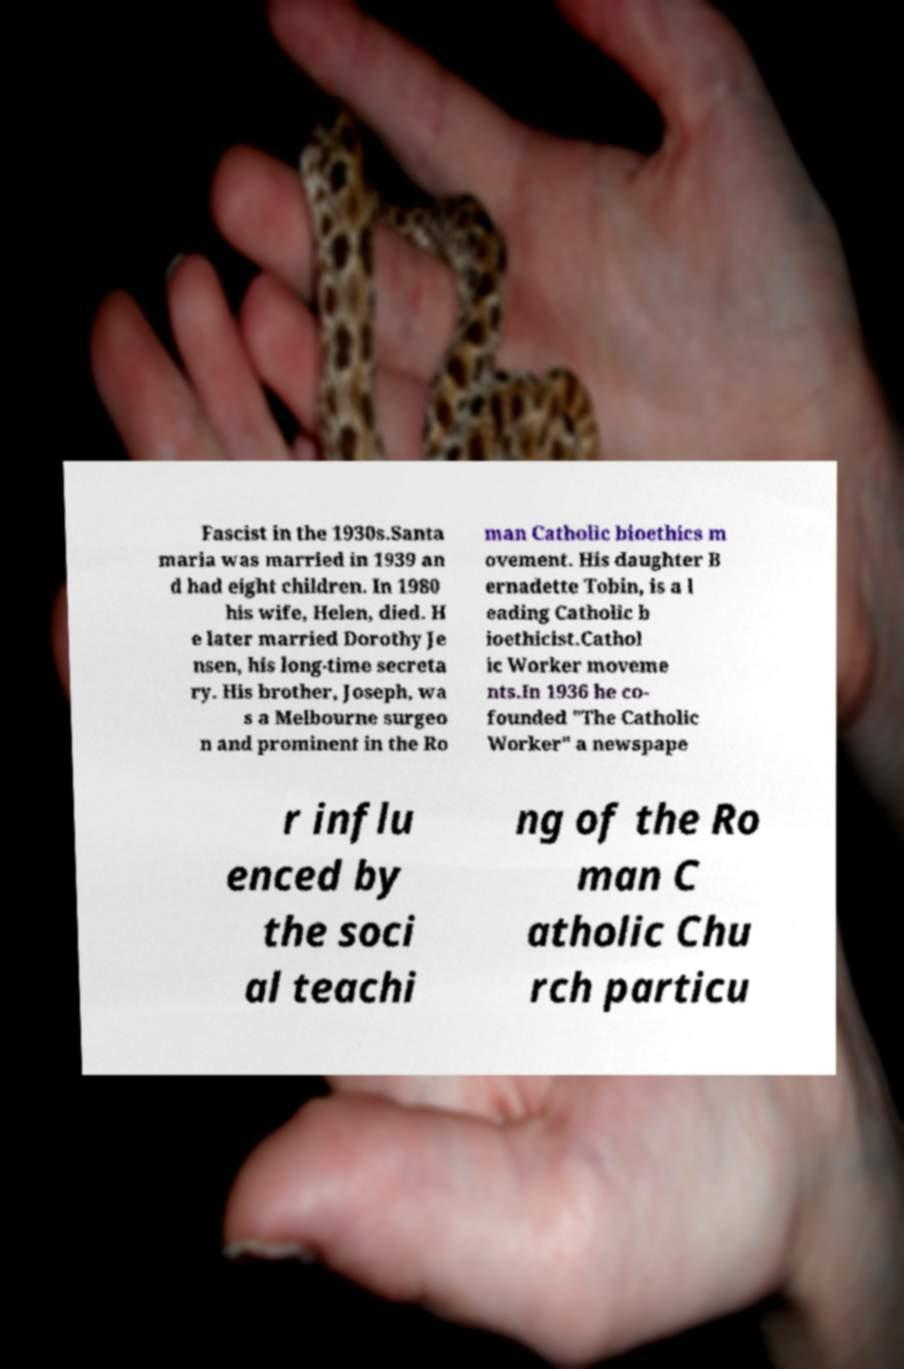What messages or text are displayed in this image? I need them in a readable, typed format. Fascist in the 1930s.Santa maria was married in 1939 an d had eight children. In 1980 his wife, Helen, died. H e later married Dorothy Je nsen, his long-time secreta ry. His brother, Joseph, wa s a Melbourne surgeo n and prominent in the Ro man Catholic bioethics m ovement. His daughter B ernadette Tobin, is a l eading Catholic b ioethicist.Cathol ic Worker moveme nts.In 1936 he co- founded "The Catholic Worker" a newspape r influ enced by the soci al teachi ng of the Ro man C atholic Chu rch particu 